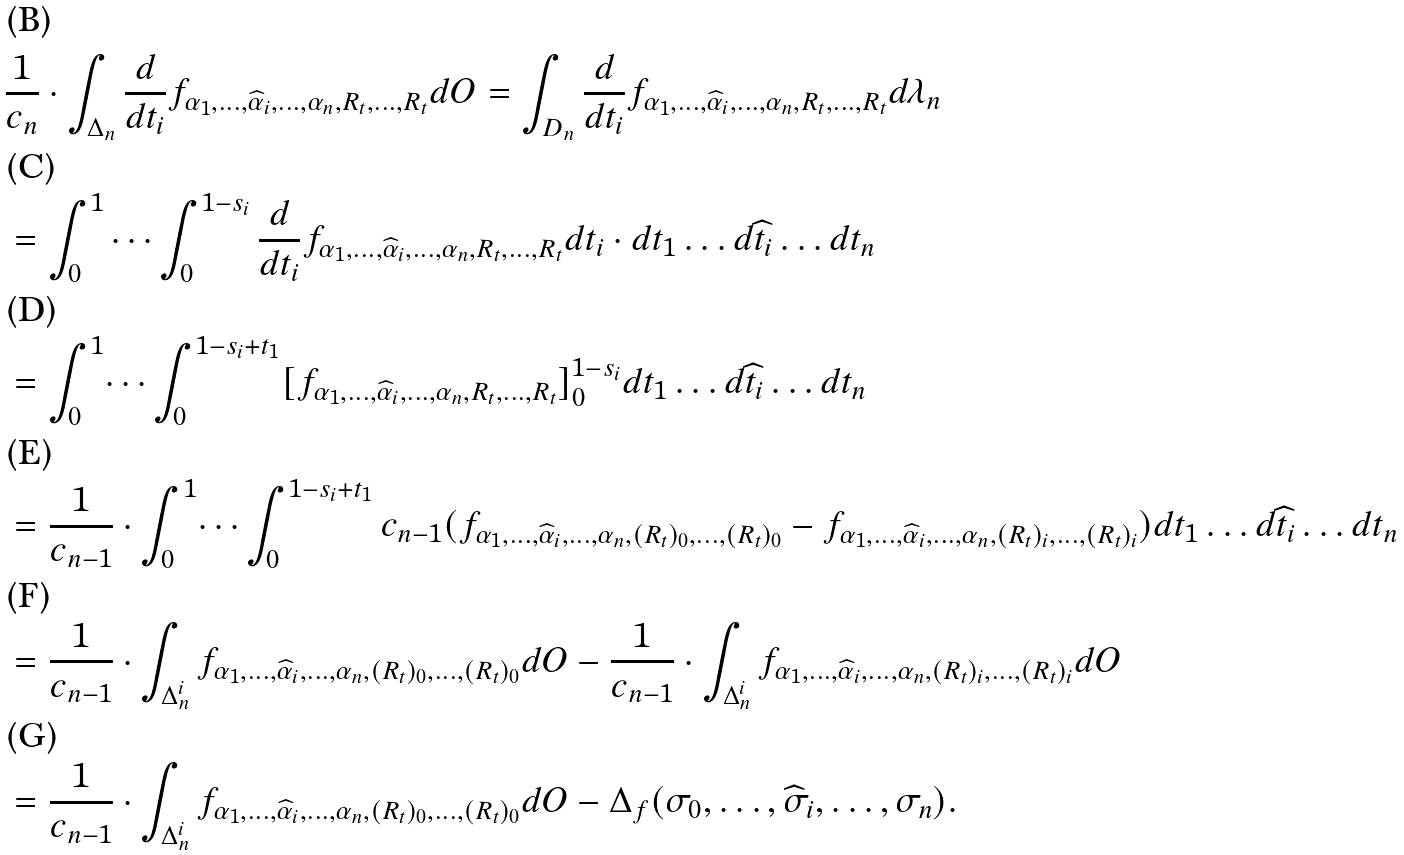<formula> <loc_0><loc_0><loc_500><loc_500>& \frac { 1 } { c _ { n } } \cdot \int _ { \Delta _ { n } } \frac { d } { d t _ { i } } f _ { \alpha _ { 1 } , \dots , \widehat { \alpha } _ { i } , \dots , \alpha _ { n } , R _ { t } , \dots , R _ { t } } d O = \int _ { D _ { n } } \frac { d } { d t _ { i } } f _ { \alpha _ { 1 } , \dots , \widehat { \alpha } _ { i } , \dots , \alpha _ { n } , R _ { t } , \dots , R _ { t } } d \lambda _ { n } \\ & = \int ^ { 1 } _ { 0 } \cdots \int ^ { 1 - s _ { i } } _ { 0 } \frac { d } { d t _ { i } } f _ { \alpha _ { 1 } , \dots , \widehat { \alpha } _ { i } , \dots , \alpha _ { n } , R _ { t } , \dots , R _ { t } } d t _ { i } \cdot d t _ { 1 } \dots d \widehat { t } _ { i } \dots d t _ { n } \\ & = \int ^ { 1 } _ { 0 } \dots \int ^ { 1 - s _ { i } + t _ { 1 } } _ { 0 } [ f _ { \alpha _ { 1 } , \dots , \widehat { \alpha } _ { i } , \dots , \alpha _ { n } , R _ { t } , \dots , R _ { t } } ] ^ { 1 - s _ { i } } _ { 0 } d t _ { 1 } \dots d \widehat { t } _ { i } \dots d t _ { n } \\ & = \frac { 1 } { c _ { n - 1 } } \cdot \int ^ { 1 } _ { 0 } \dots \int ^ { 1 - s _ { i } + t _ { 1 } } _ { 0 } c _ { n - 1 } ( f _ { \alpha _ { 1 } , \dots , \widehat { \alpha } _ { i } , \dots , \alpha _ { n } , ( R _ { t } ) _ { 0 } , \dots , ( R _ { t } ) _ { 0 } } - f _ { \alpha _ { 1 } , \dots , \widehat { \alpha } _ { i } , \dots , \alpha _ { n } , ( R _ { t } ) _ { i } , \dots , ( R _ { t } ) _ { i } } ) d t _ { 1 } \dots d \widehat { t } _ { i } \dots d t _ { n } \\ & = \frac { 1 } { c _ { n - 1 } } \cdot \int _ { \Delta ^ { i } _ { n } } f _ { \alpha _ { 1 } , \dots , \widehat { \alpha } _ { i } , \dots , \alpha _ { n } , ( R _ { t } ) _ { 0 } , \dots , ( R _ { t } ) _ { 0 } } d O - \frac { 1 } { c _ { n - 1 } } \cdot \int _ { \Delta ^ { i } _ { n } } f _ { \alpha _ { 1 } , \dots , \widehat { \alpha } _ { i } , \dots , \alpha _ { n } , ( R _ { t } ) _ { i } , \dots , ( R _ { t } ) _ { i } } d O \\ & = \frac { 1 } { c _ { n - 1 } } \cdot \int _ { \Delta ^ { i } _ { n } } f _ { \alpha _ { 1 } , \dots , \widehat { \alpha } _ { i } , \dots , \alpha _ { n } , ( R _ { t } ) _ { 0 } , \dots , ( R _ { t } ) _ { 0 } } d O - \Delta _ { f } ( \sigma _ { 0 } , \dots , \widehat { \sigma } _ { i } , \dots , \sigma _ { n } ) .</formula> 